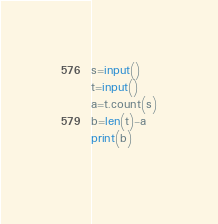<code> <loc_0><loc_0><loc_500><loc_500><_Python_>s=input()
t=input()
a=t.count(s)
b=len(t)-a
print(b)
  </code> 